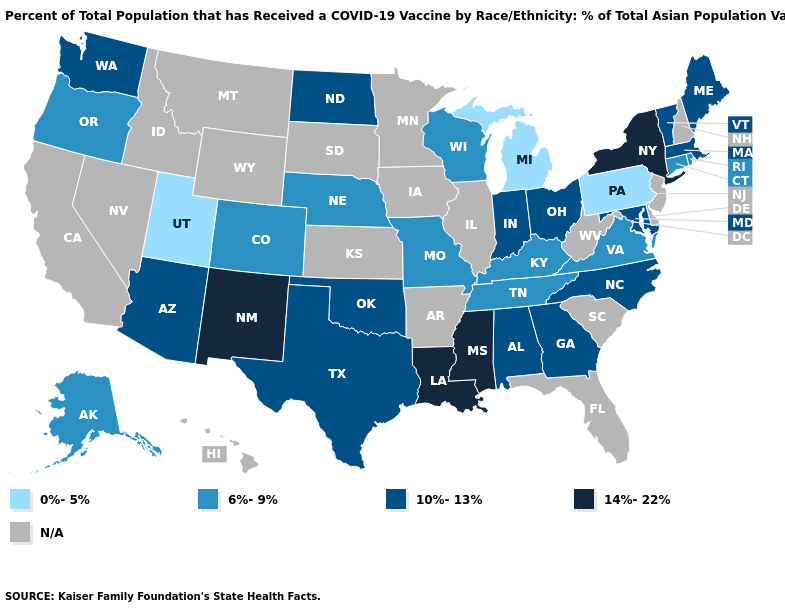What is the lowest value in the West?
Keep it brief. 0%-5%. Name the states that have a value in the range 0%-5%?
Concise answer only. Michigan, Pennsylvania, Utah. Does Utah have the lowest value in the USA?
Give a very brief answer. Yes. What is the value of Michigan?
Write a very short answer. 0%-5%. What is the highest value in states that border Texas?
Be succinct. 14%-22%. Does the map have missing data?
Write a very short answer. Yes. Name the states that have a value in the range 0%-5%?
Keep it brief. Michigan, Pennsylvania, Utah. Name the states that have a value in the range 10%-13%?
Keep it brief. Alabama, Arizona, Georgia, Indiana, Maine, Maryland, Massachusetts, North Carolina, North Dakota, Ohio, Oklahoma, Texas, Vermont, Washington. Which states have the lowest value in the USA?
Write a very short answer. Michigan, Pennsylvania, Utah. What is the value of New Jersey?
Be succinct. N/A. What is the value of Louisiana?
Concise answer only. 14%-22%. How many symbols are there in the legend?
Give a very brief answer. 5. Does Michigan have the lowest value in the USA?
Keep it brief. Yes. 